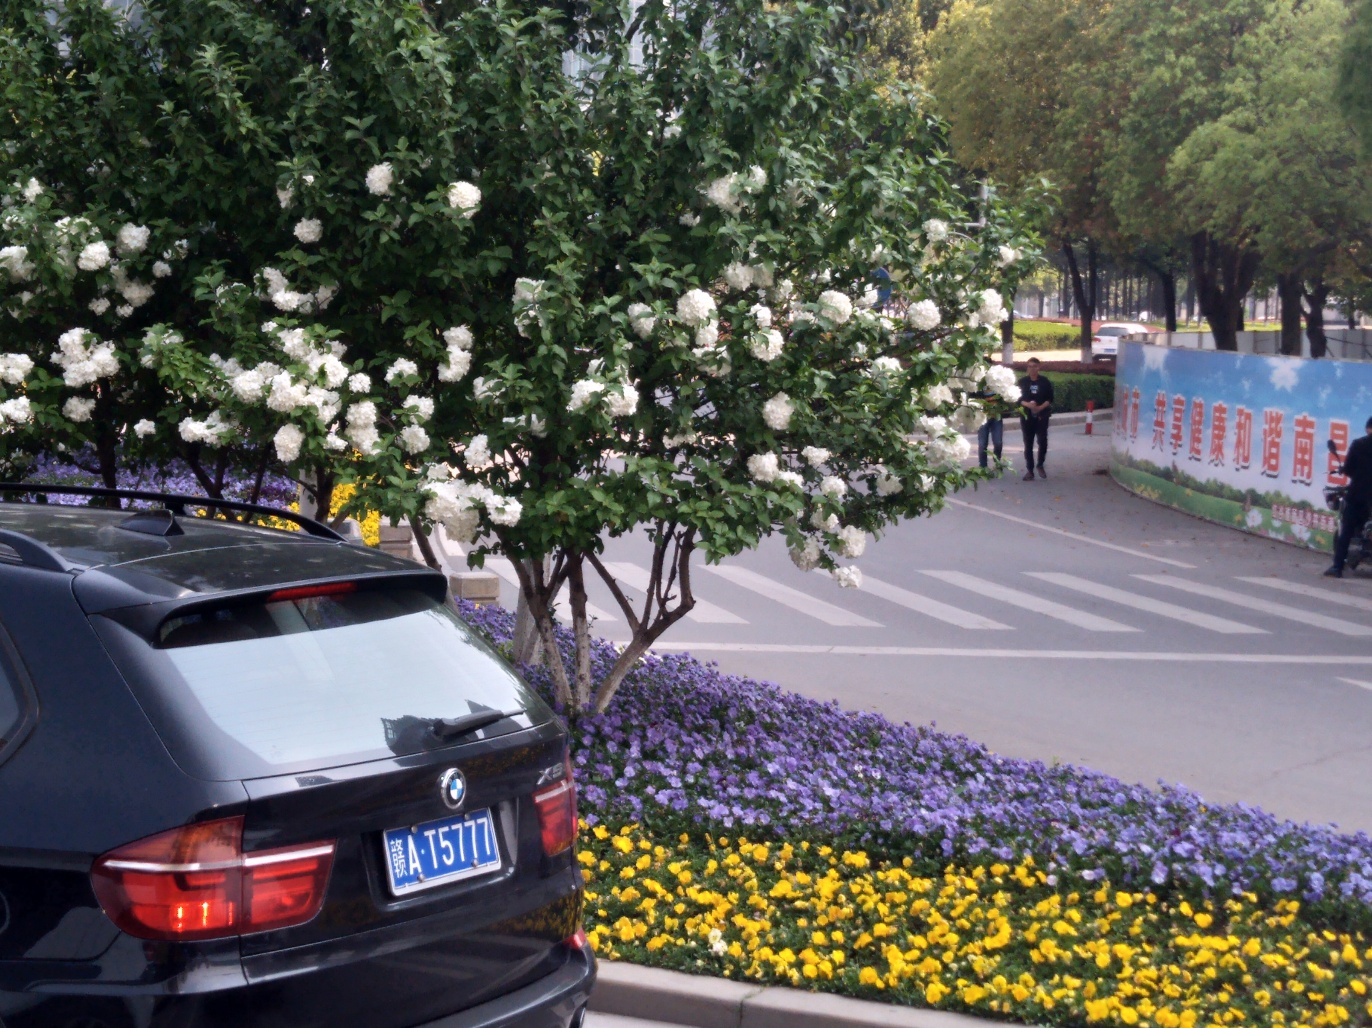What is the make and model of the car in the image? The car in the image is a black BMW X5, identifiable by its distinctive emblem and design. It's a luxury mid-size SUV that's parked alongside a curb, with its brake lights illuminated, indicating that the vehicle is not currently in motion. 